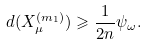<formula> <loc_0><loc_0><loc_500><loc_500>d ( X _ { \mu } ^ { ( m _ { 1 } ) } ) \geqslant \frac { 1 } { 2 n } \psi _ { \omega } .</formula> 